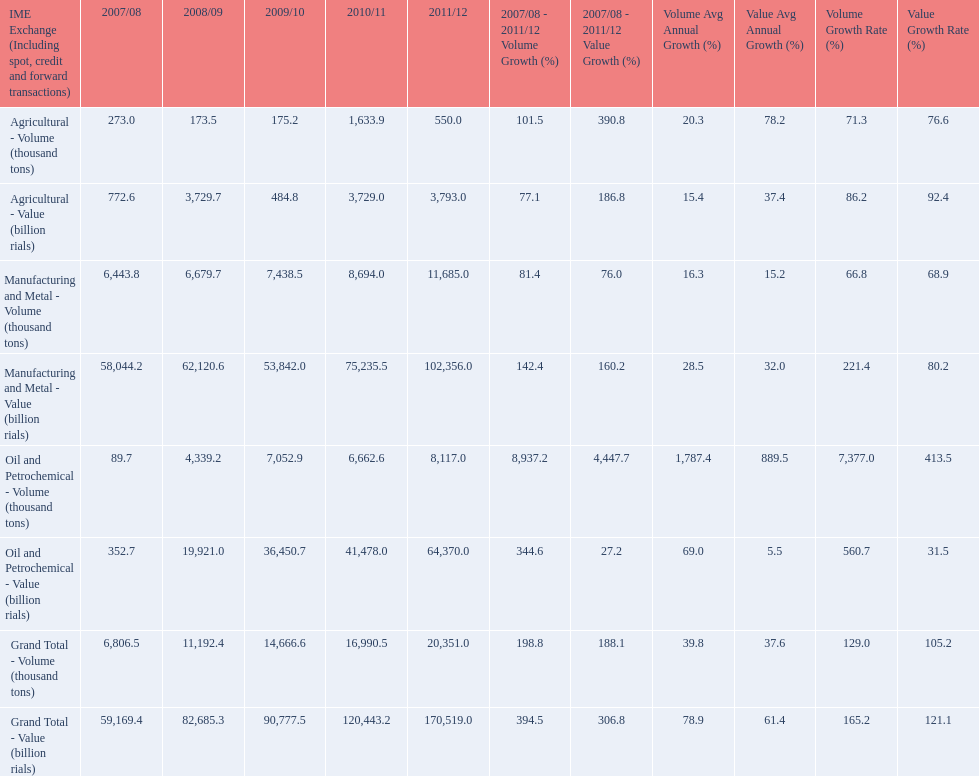What year saw the greatest value for manufacturing and metal in iran? 2011/12. 